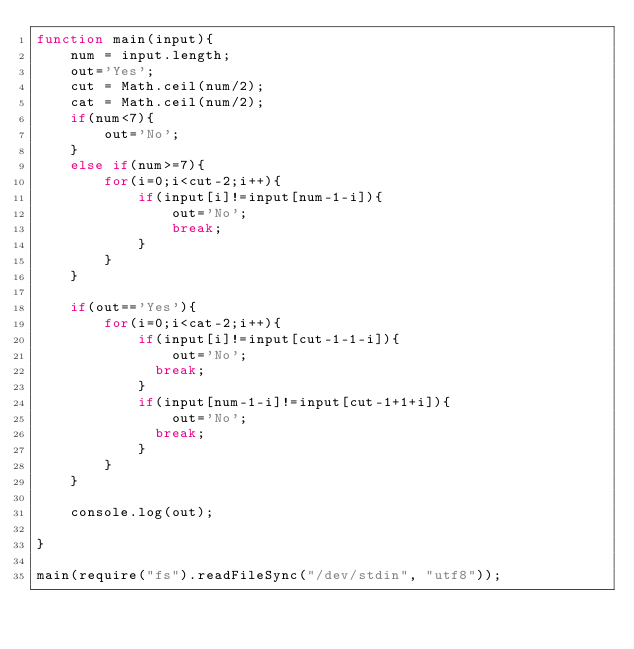<code> <loc_0><loc_0><loc_500><loc_500><_JavaScript_>function main(input){
    num = input.length;
    out='Yes';
    cut = Math.ceil(num/2);
    cat = Math.ceil(num/2);
    if(num<7){
        out='No';
    }
    else if(num>=7){
        for(i=0;i<cut-2;i++){
            if(input[i]!=input[num-1-i]){
                out='No';
                break;
            }
        }
    }
  
    if(out=='Yes'){
        for(i=0;i<cat-2;i++){
            if(input[i]!=input[cut-1-1-i]){
                out='No';
              break;
            }
            if(input[num-1-i]!=input[cut-1+1+i]){
                out='No';
              break;
            }
        }
    }

    console.log(out);

}

main(require("fs").readFileSync("/dev/stdin", "utf8"));</code> 